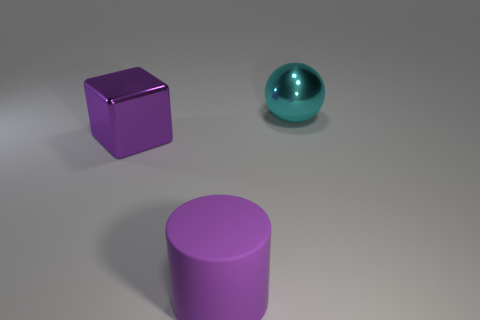Subtract 1 balls. How many balls are left? 0 Subtract all balls. How many objects are left? 2 Add 2 cyan things. How many objects exist? 5 Subtract 1 cyan balls. How many objects are left? 2 Subtract all yellow cubes. Subtract all green cylinders. How many cubes are left? 1 Subtract all red cylinders. How many gray cubes are left? 0 Subtract all purple rubber cylinders. Subtract all purple cylinders. How many objects are left? 1 Add 2 purple cylinders. How many purple cylinders are left? 3 Add 3 yellow cubes. How many yellow cubes exist? 3 